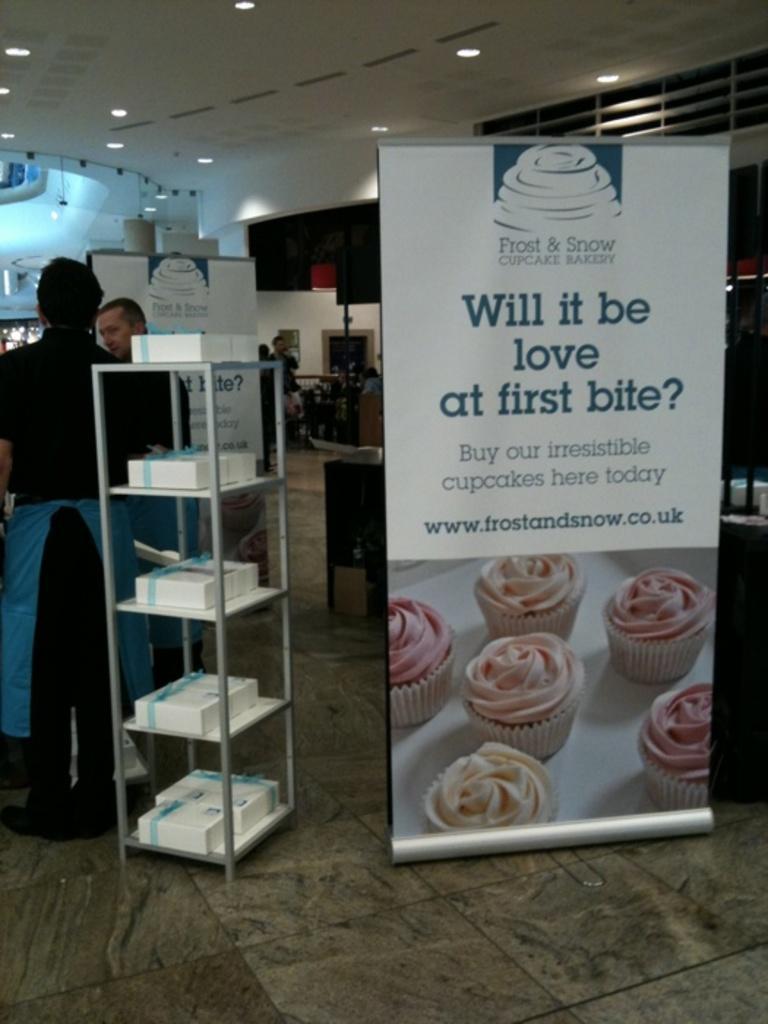Please provide a concise description of this image. In this image there are two persons visible in front of a stand , on a stand I can see some boxes ,there is a board visible on the right side, on board I can see there is a picture of cakes and text and in the middle there are few persons, table,roof , lights attached to the roof visible. 